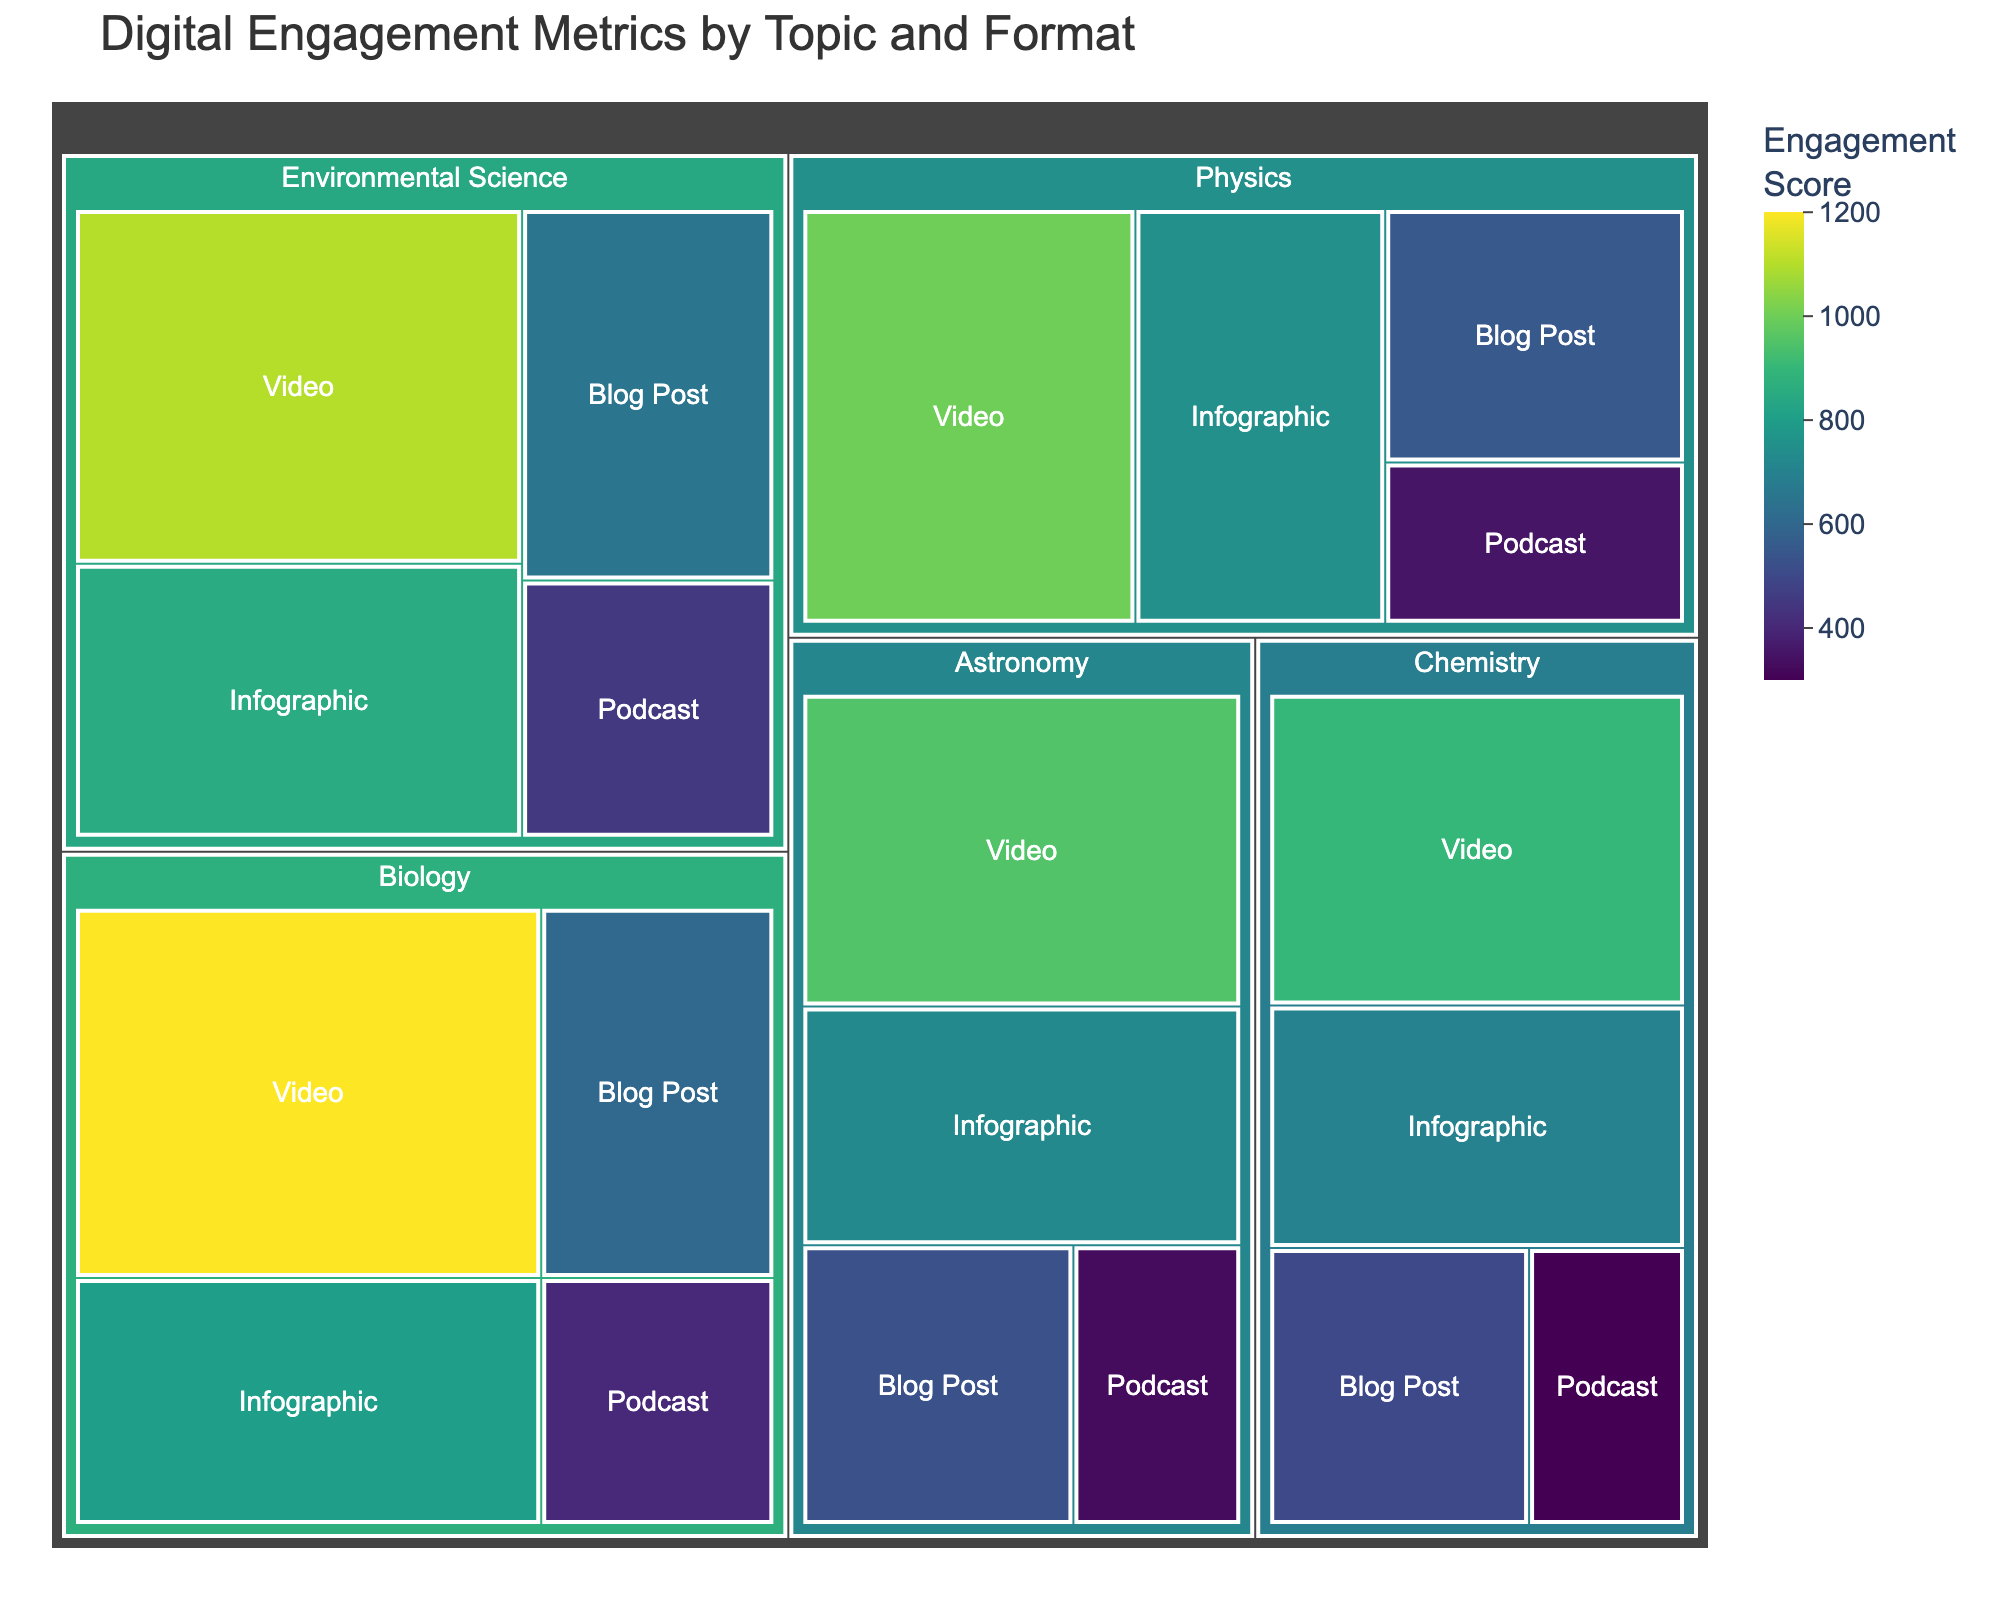what is the engagement score for Biology video? Locate the tile labeled "Biology" that contains the sub-label "Video" and read the corresponding engagement score.
Answer: 1200 Which format has the lowest engagement score for Chemistry? In the Chemistry category, compare the engagement scores for Video, Infographic, Blog Post, and Podcast formats to identify the lowest one.
Answer: Podcast What's the average engagement score for Astronomy across all formats? Add up the engagement scores for all Astronomy formats (Video: 950, Infographic: 725, Blog Post: 525, Podcast: 325), then divide by the number of formats (4). (950 + 725 + 525 + 325) / 4 = 2525 / 4 = 631.25
Answer: 631.25 How does the engagement score for Environmental Science Infographic compare to the engagement score for Physics Blog Post? Find the engagement score for Environmental Science Infographic (850) and Physics Blog Post (550) and compare them.
Answer: The Environmental Science Infographic score is higher Which topic has the highest engagement score overall, and which format contributes to it? Sum the engagement scores for each format under each topic and identify which topic has the highest overall engagement score, then identify which format in that topic has the highest score.
Answer: Biology, Video What's the total engagement score for Blog Posts across all topics? Add the engagement scores for Blog Posts under each topic (Biology: 600, Chemistry: 500, Physics: 550, Environmental Science: 650, Astronomy: 525). (600 + 500 + 550 + 650 + 525) = 2825
Answer: 2825 Which format has the most balanced engagement scores across different topics? Evaluate the consistency of engagement scores for each format (Video, Infographic, Blog Post, Podcast) across all topics, identifying the format with the least variation in scores.
Answer: Infographic How does the engagement score of a Video in Astronomy compare to a Video in Chemistry? Locate the engagement scores for Videos in Astronomy and Chemistry, which are 950 and 900 respectively, and compare the two values.
Answer: Astronomy Video score is higher What is the combined engagement score for Videos and Infographics in Environmental Science? Add the engagement score for Video (1100) and Infographic (850) in the Environmental Science topic. 1100 + 850 = 1950
Answer: 1950 